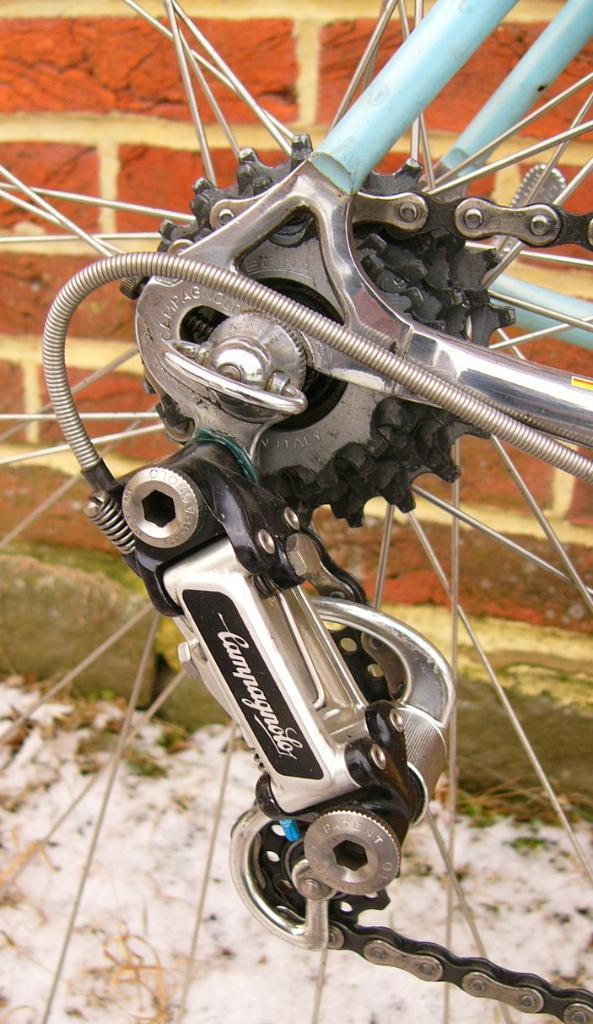How would you summarize this image in a sentence or two? In this picture I can see the rims, a chain, few rods and the gear set. In the background I can see the wall. 